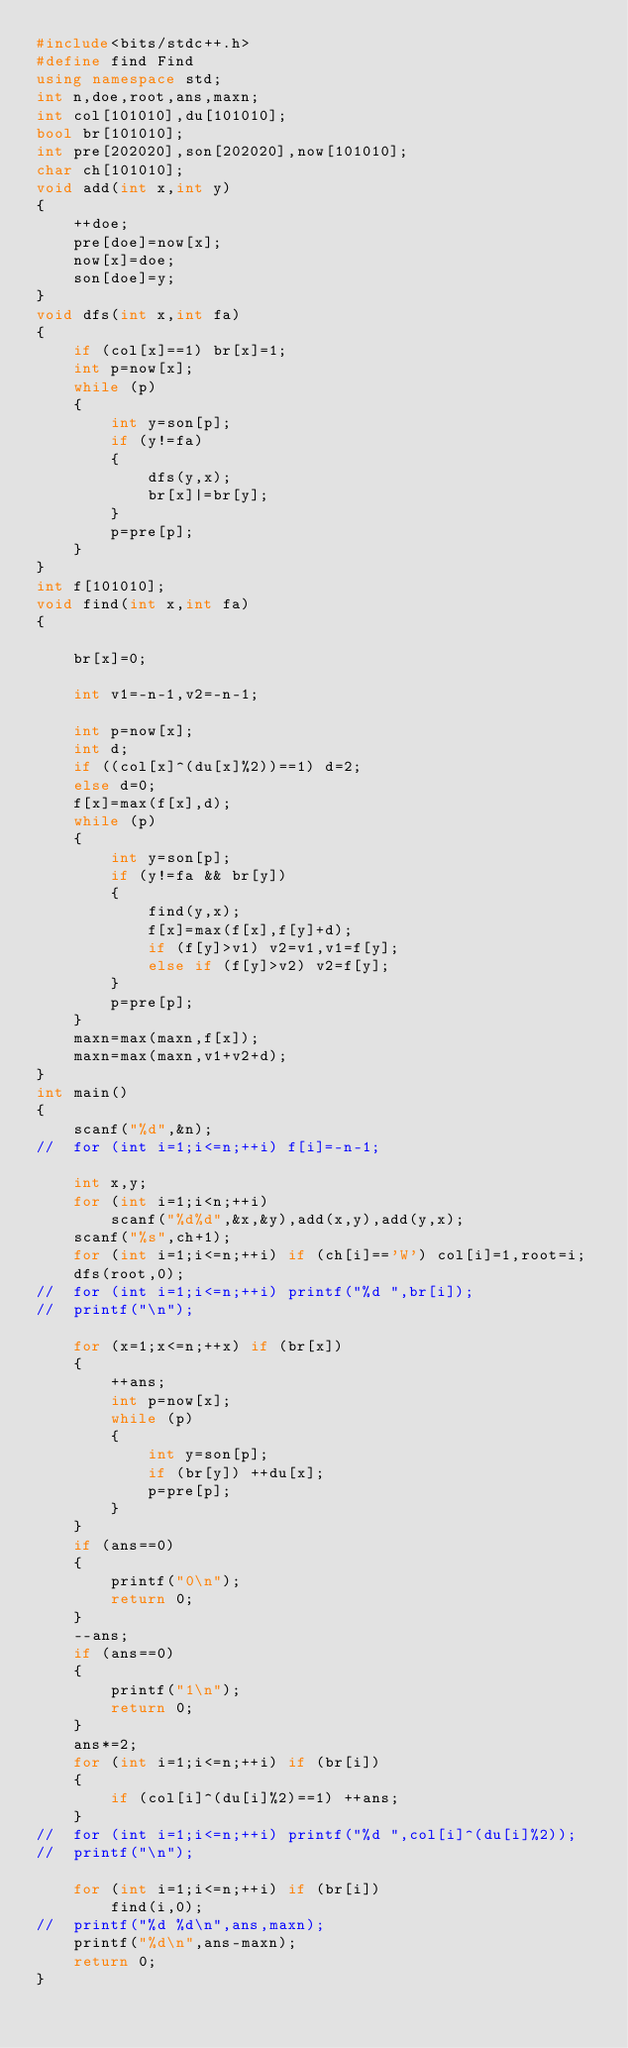Convert code to text. <code><loc_0><loc_0><loc_500><loc_500><_C++_>#include<bits/stdc++.h>
#define find Find
using namespace std;
int n,doe,root,ans,maxn;
int col[101010],du[101010];
bool br[101010];
int pre[202020],son[202020],now[101010];
char ch[101010];
void add(int x,int y)
{
	++doe;
	pre[doe]=now[x];
	now[x]=doe;
	son[doe]=y;
}
void dfs(int x,int fa)
{
	if (col[x]==1) br[x]=1;
	int p=now[x];
	while (p)
	{
		int y=son[p];
		if (y!=fa)
		{
			dfs(y,x);
			br[x]|=br[y];
		}
		p=pre[p];
	}
}
int f[101010];
void find(int x,int fa)
{

	br[x]=0;

	int v1=-n-1,v2=-n-1;
	
	int p=now[x];
	int d;
	if ((col[x]^(du[x]%2))==1) d=2;
	else d=0;
	f[x]=max(f[x],d);
	while (p)
	{
		int y=son[p];
		if (y!=fa && br[y])
		{
			find(y,x);
			f[x]=max(f[x],f[y]+d);
			if (f[y]>v1) v2=v1,v1=f[y];
			else if (f[y]>v2) v2=f[y];
		}
		p=pre[p];
	}
	maxn=max(maxn,f[x]);
	maxn=max(maxn,v1+v2+d);
}
int main()
{
	scanf("%d",&n);
//	for (int i=1;i<=n;++i) f[i]=-n-1;

	int x,y;
	for (int i=1;i<n;++i)
		scanf("%d%d",&x,&y),add(x,y),add(y,x);
	scanf("%s",ch+1);
	for (int i=1;i<=n;++i) if (ch[i]=='W') col[i]=1,root=i;
	dfs(root,0);
//	for (int i=1;i<=n;++i) printf("%d ",br[i]);
//	printf("\n");

	for (x=1;x<=n;++x) if (br[x])
	{
		++ans;
		int p=now[x];
		while (p)
		{
			int y=son[p];
			if (br[y]) ++du[x];
			p=pre[p];
		}
	}
	if (ans==0)
	{
		printf("0\n");
		return 0;
	}
	--ans;
	if (ans==0)
	{
		printf("1\n");
		return 0;
	}
	ans*=2;
	for (int i=1;i<=n;++i) if (br[i])
	{
		if (col[i]^(du[i]%2)==1) ++ans;
	}
//	for (int i=1;i<=n;++i) printf("%d ",col[i]^(du[i]%2));
//	printf("\n");

	for (int i=1;i<=n;++i) if (br[i])
		find(i,0);
//	printf("%d %d\n",ans,maxn);
	printf("%d\n",ans-maxn);
	return 0;
}</code> 